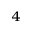<formula> <loc_0><loc_0><loc_500><loc_500>^ { 4 }</formula> 